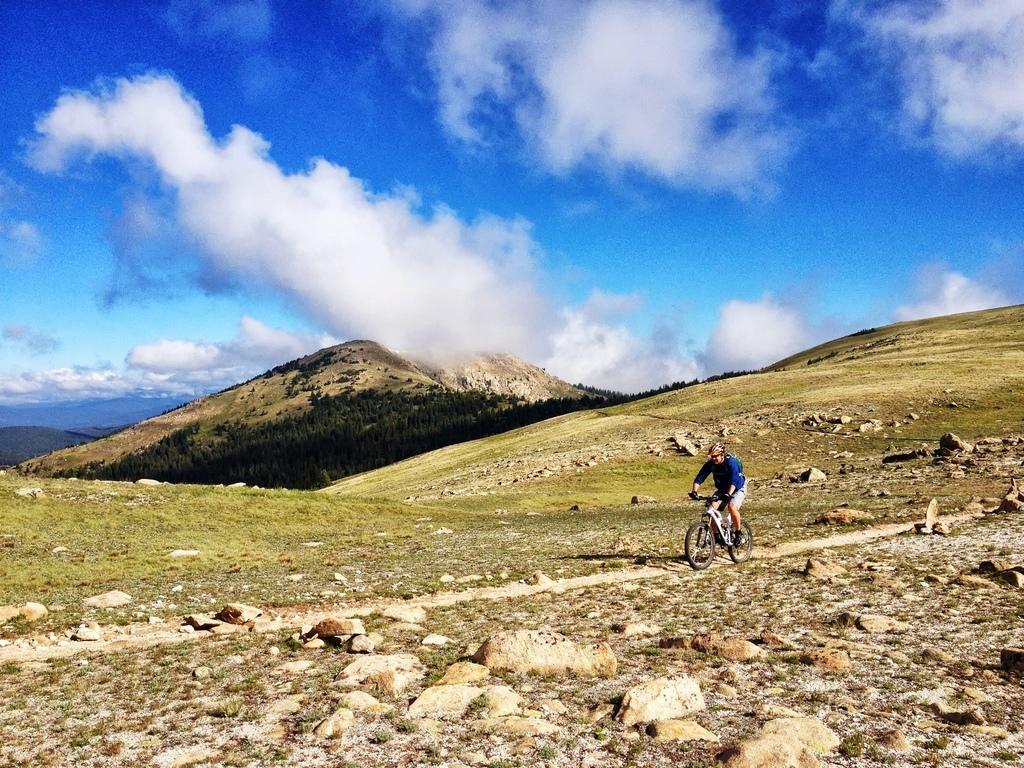Can you describe this image briefly? In this picture I can see a person wearing the helmet and riding the bicycle. I can see the hills in the background. I can see trees. I can see clouds in the sky. 